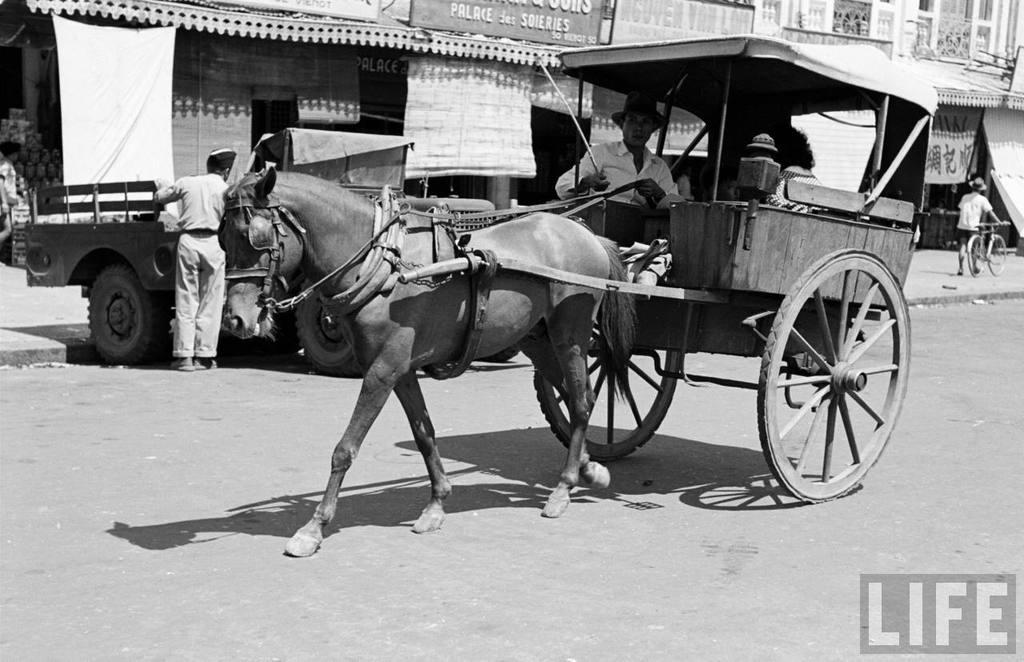What is the main subject of the image? The main subject of the image is a horse and cart. Who is present on the horse and cart? A man is present on the horse and cart. What is the man wearing? The man is wearing a shirt and hat. What can be seen in the background of the image? There is a vehicle, people, a cycle, and a building visible in the background of the image. What type of crayon is the writer using to draw the scarecrow in the image? There is no writer, scarecrow, or crayon present in the image. 